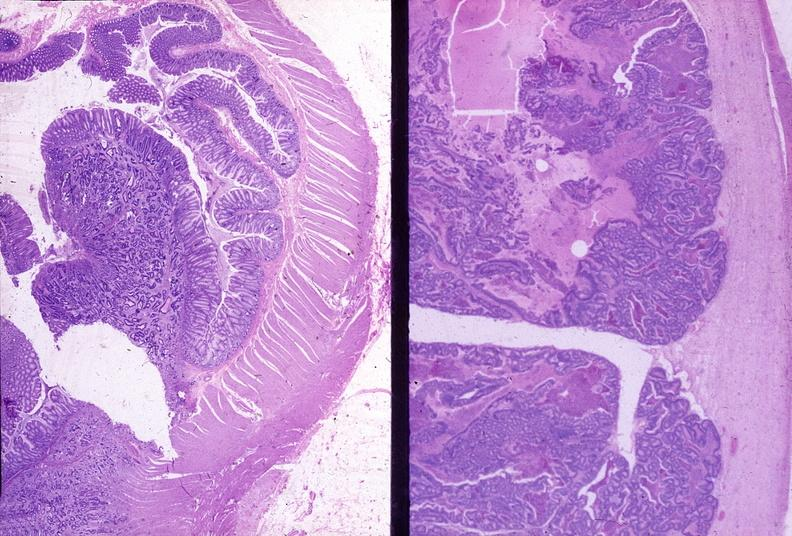what does this image show?
Answer the question using a single word or phrase. Colon 